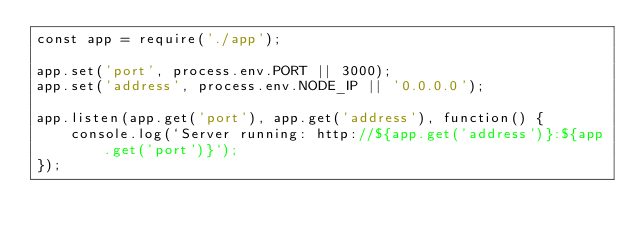Convert code to text. <code><loc_0><loc_0><loc_500><loc_500><_JavaScript_>const app = require('./app');

app.set('port', process.env.PORT || 3000);
app.set('address', process.env.NODE_IP || '0.0.0.0');

app.listen(app.get('port'), app.get('address'), function() {
    console.log(`Server running: http://${app.get('address')}:${app.get('port')}`);
});
</code> 